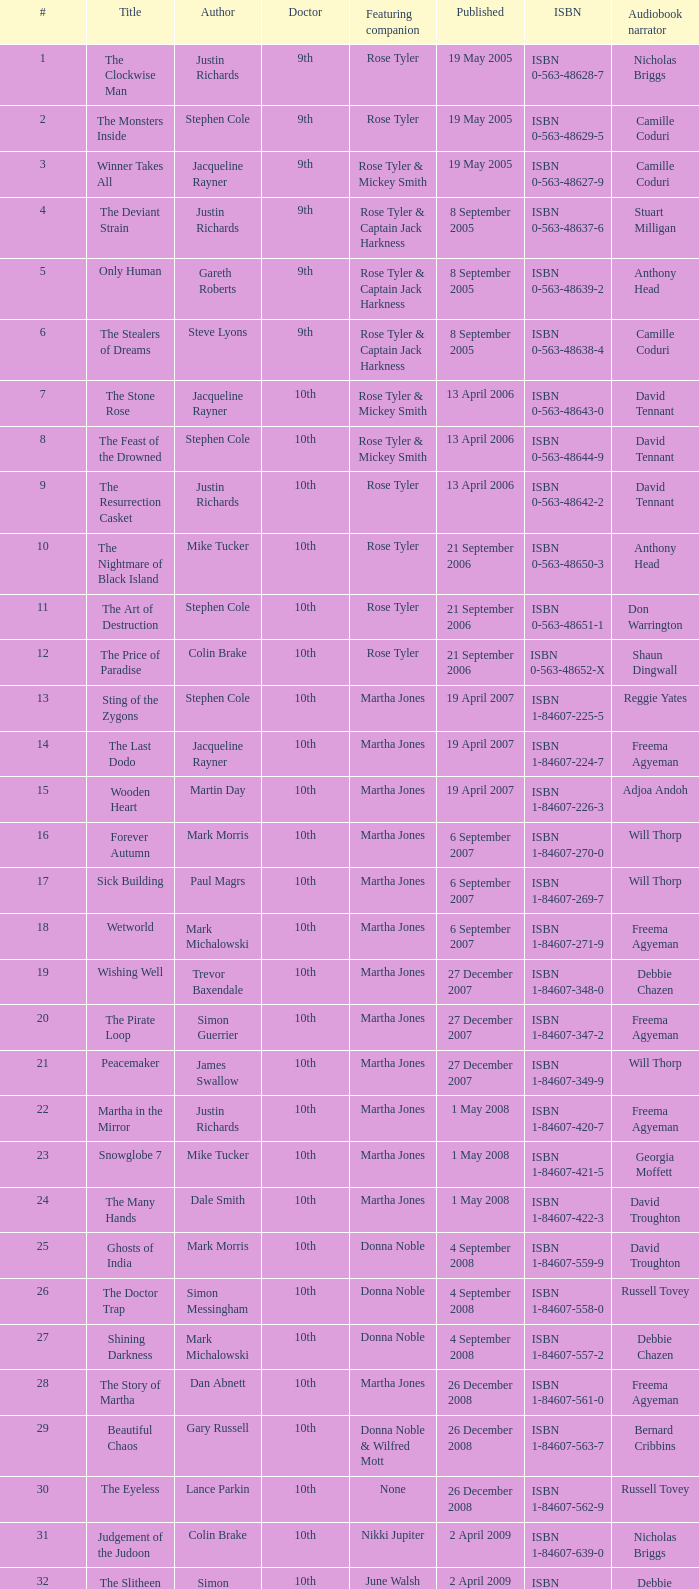Who are the associated counterparts of number 3? Rose Tyler & Mickey Smith. 